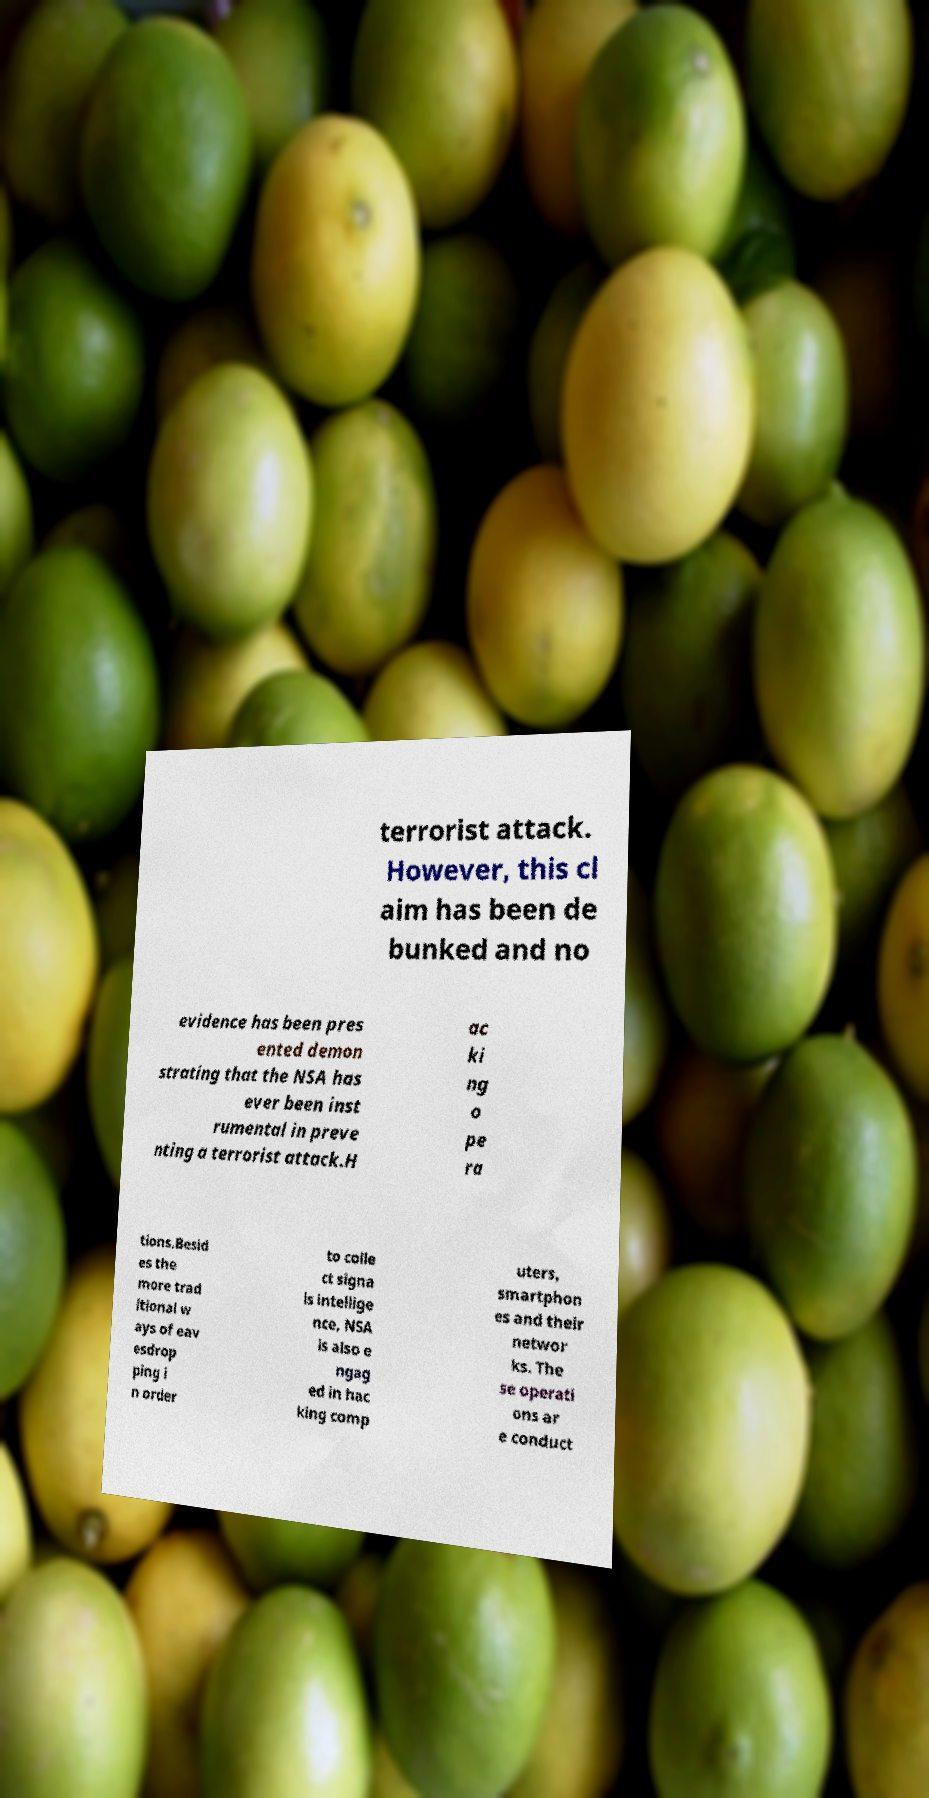Could you assist in decoding the text presented in this image and type it out clearly? terrorist attack. However, this cl aim has been de bunked and no evidence has been pres ented demon strating that the NSA has ever been inst rumental in preve nting a terrorist attack.H ac ki ng o pe ra tions.Besid es the more trad itional w ays of eav esdrop ping i n order to colle ct signa ls intellige nce, NSA is also e ngag ed in hac king comp uters, smartphon es and their networ ks. The se operati ons ar e conduct 